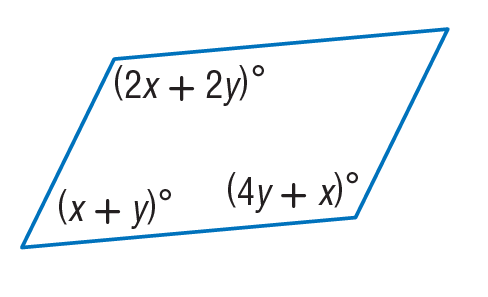Answer the mathemtical geometry problem and directly provide the correct option letter.
Question: Find y so that the quadrilateral is a parallelogram.
Choices: A: 11 B: 15 C: 20 D: 30 C 